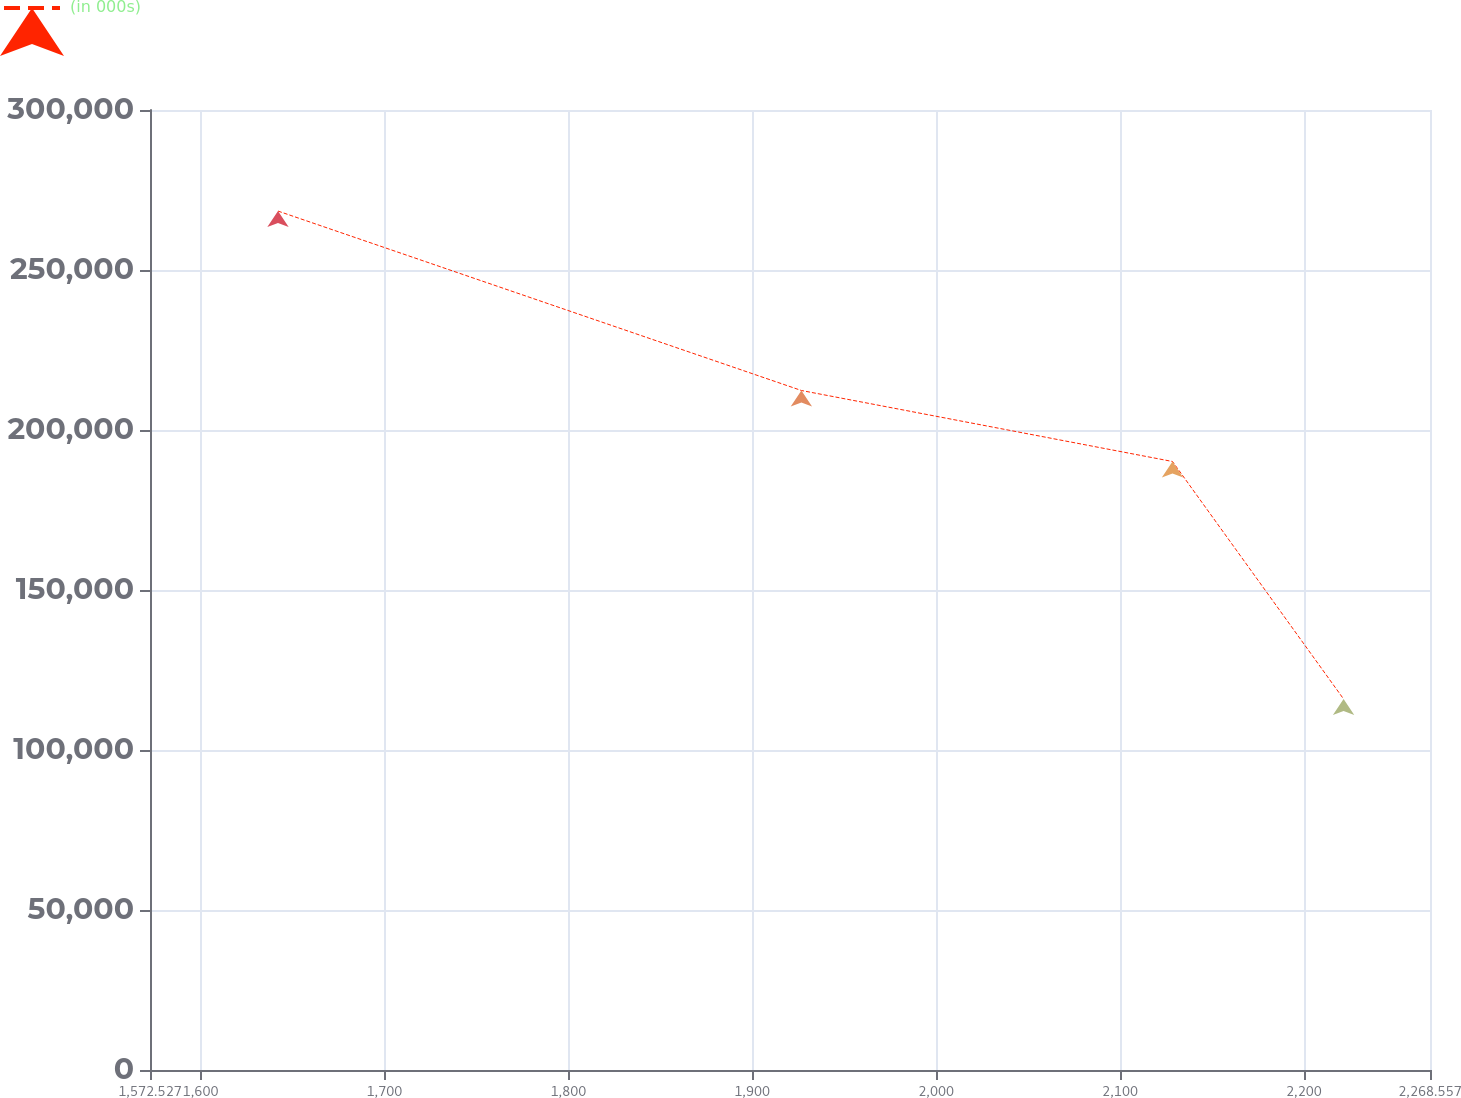Convert chart to OTSL. <chart><loc_0><loc_0><loc_500><loc_500><line_chart><ecel><fcel>(in 000s)<nl><fcel>1642.13<fcel>268416<nl><fcel>1926.73<fcel>212347<nl><fcel>2128.54<fcel>190156<nl><fcel>2221.57<fcel>115925<nl><fcel>2338.16<fcel>46506.8<nl></chart> 